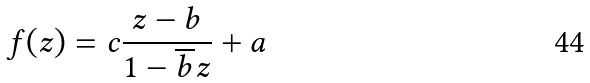Convert formula to latex. <formula><loc_0><loc_0><loc_500><loc_500>f ( z ) = c \frac { z - b } { 1 - \overline { b } z } + a</formula> 